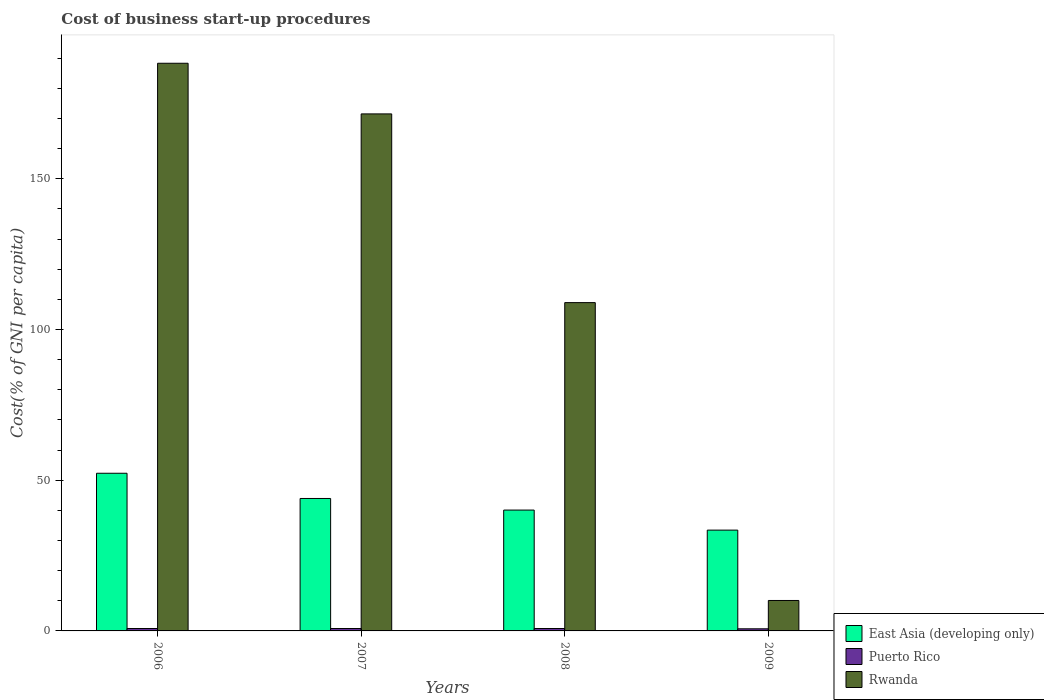How many groups of bars are there?
Your answer should be very brief. 4. Are the number of bars per tick equal to the number of legend labels?
Provide a succinct answer. Yes. Are the number of bars on each tick of the X-axis equal?
Your answer should be compact. Yes. How many bars are there on the 4th tick from the right?
Your response must be concise. 3. What is the label of the 2nd group of bars from the left?
Give a very brief answer. 2007. In how many cases, is the number of bars for a given year not equal to the number of legend labels?
Give a very brief answer. 0. What is the cost of business start-up procedures in East Asia (developing only) in 2009?
Ensure brevity in your answer.  33.44. Across all years, what is the minimum cost of business start-up procedures in East Asia (developing only)?
Your response must be concise. 33.44. What is the total cost of business start-up procedures in Rwanda in the graph?
Ensure brevity in your answer.  478.8. What is the difference between the cost of business start-up procedures in East Asia (developing only) in 2007 and the cost of business start-up procedures in Rwanda in 2008?
Provide a short and direct response. -64.97. What is the average cost of business start-up procedures in East Asia (developing only) per year?
Keep it short and to the point. 42.44. In the year 2007, what is the difference between the cost of business start-up procedures in Rwanda and cost of business start-up procedures in Puerto Rico?
Make the answer very short. 170.7. What is the ratio of the cost of business start-up procedures in East Asia (developing only) in 2006 to that in 2007?
Give a very brief answer. 1.19. Is the difference between the cost of business start-up procedures in Rwanda in 2008 and 2009 greater than the difference between the cost of business start-up procedures in Puerto Rico in 2008 and 2009?
Offer a very short reply. Yes. What is the difference between the highest and the second highest cost of business start-up procedures in East Asia (developing only)?
Provide a succinct answer. 8.37. What is the difference between the highest and the lowest cost of business start-up procedures in Rwanda?
Provide a succinct answer. 178.2. Is the sum of the cost of business start-up procedures in East Asia (developing only) in 2008 and 2009 greater than the maximum cost of business start-up procedures in Rwanda across all years?
Keep it short and to the point. No. What does the 2nd bar from the left in 2009 represents?
Offer a very short reply. Puerto Rico. What does the 3rd bar from the right in 2009 represents?
Give a very brief answer. East Asia (developing only). Is it the case that in every year, the sum of the cost of business start-up procedures in East Asia (developing only) and cost of business start-up procedures in Puerto Rico is greater than the cost of business start-up procedures in Rwanda?
Keep it short and to the point. No. How many bars are there?
Provide a succinct answer. 12. Does the graph contain any zero values?
Your response must be concise. No. Does the graph contain grids?
Your answer should be very brief. No. What is the title of the graph?
Your response must be concise. Cost of business start-up procedures. What is the label or title of the Y-axis?
Provide a succinct answer. Cost(% of GNI per capita). What is the Cost(% of GNI per capita) of East Asia (developing only) in 2006?
Offer a very short reply. 52.3. What is the Cost(% of GNI per capita) in Rwanda in 2006?
Your response must be concise. 188.3. What is the Cost(% of GNI per capita) in East Asia (developing only) in 2007?
Provide a short and direct response. 43.93. What is the Cost(% of GNI per capita) in Rwanda in 2007?
Offer a very short reply. 171.5. What is the Cost(% of GNI per capita) of East Asia (developing only) in 2008?
Provide a succinct answer. 40.09. What is the Cost(% of GNI per capita) of Rwanda in 2008?
Your answer should be very brief. 108.9. What is the Cost(% of GNI per capita) in East Asia (developing only) in 2009?
Give a very brief answer. 33.44. What is the Cost(% of GNI per capita) of Rwanda in 2009?
Keep it short and to the point. 10.1. Across all years, what is the maximum Cost(% of GNI per capita) in East Asia (developing only)?
Your answer should be very brief. 52.3. Across all years, what is the maximum Cost(% of GNI per capita) in Rwanda?
Your response must be concise. 188.3. Across all years, what is the minimum Cost(% of GNI per capita) of East Asia (developing only)?
Offer a terse response. 33.44. Across all years, what is the minimum Cost(% of GNI per capita) in Puerto Rico?
Provide a short and direct response. 0.7. What is the total Cost(% of GNI per capita) of East Asia (developing only) in the graph?
Offer a terse response. 169.76. What is the total Cost(% of GNI per capita) in Rwanda in the graph?
Give a very brief answer. 478.8. What is the difference between the Cost(% of GNI per capita) in East Asia (developing only) in 2006 and that in 2007?
Make the answer very short. 8.37. What is the difference between the Cost(% of GNI per capita) of Puerto Rico in 2006 and that in 2007?
Provide a short and direct response. 0. What is the difference between the Cost(% of GNI per capita) in East Asia (developing only) in 2006 and that in 2008?
Offer a terse response. 12.21. What is the difference between the Cost(% of GNI per capita) of Puerto Rico in 2006 and that in 2008?
Offer a terse response. 0. What is the difference between the Cost(% of GNI per capita) in Rwanda in 2006 and that in 2008?
Keep it short and to the point. 79.4. What is the difference between the Cost(% of GNI per capita) in East Asia (developing only) in 2006 and that in 2009?
Your response must be concise. 18.86. What is the difference between the Cost(% of GNI per capita) of Rwanda in 2006 and that in 2009?
Keep it short and to the point. 178.2. What is the difference between the Cost(% of GNI per capita) of East Asia (developing only) in 2007 and that in 2008?
Provide a succinct answer. 3.84. What is the difference between the Cost(% of GNI per capita) in Puerto Rico in 2007 and that in 2008?
Provide a short and direct response. 0. What is the difference between the Cost(% of GNI per capita) in Rwanda in 2007 and that in 2008?
Offer a very short reply. 62.6. What is the difference between the Cost(% of GNI per capita) in East Asia (developing only) in 2007 and that in 2009?
Your answer should be very brief. 10.49. What is the difference between the Cost(% of GNI per capita) of Rwanda in 2007 and that in 2009?
Your answer should be compact. 161.4. What is the difference between the Cost(% of GNI per capita) of East Asia (developing only) in 2008 and that in 2009?
Make the answer very short. 6.65. What is the difference between the Cost(% of GNI per capita) in Rwanda in 2008 and that in 2009?
Provide a succinct answer. 98.8. What is the difference between the Cost(% of GNI per capita) in East Asia (developing only) in 2006 and the Cost(% of GNI per capita) in Puerto Rico in 2007?
Ensure brevity in your answer.  51.5. What is the difference between the Cost(% of GNI per capita) of East Asia (developing only) in 2006 and the Cost(% of GNI per capita) of Rwanda in 2007?
Your response must be concise. -119.2. What is the difference between the Cost(% of GNI per capita) of Puerto Rico in 2006 and the Cost(% of GNI per capita) of Rwanda in 2007?
Offer a terse response. -170.7. What is the difference between the Cost(% of GNI per capita) of East Asia (developing only) in 2006 and the Cost(% of GNI per capita) of Puerto Rico in 2008?
Your answer should be very brief. 51.5. What is the difference between the Cost(% of GNI per capita) in East Asia (developing only) in 2006 and the Cost(% of GNI per capita) in Rwanda in 2008?
Give a very brief answer. -56.6. What is the difference between the Cost(% of GNI per capita) of Puerto Rico in 2006 and the Cost(% of GNI per capita) of Rwanda in 2008?
Offer a very short reply. -108.1. What is the difference between the Cost(% of GNI per capita) in East Asia (developing only) in 2006 and the Cost(% of GNI per capita) in Puerto Rico in 2009?
Your response must be concise. 51.6. What is the difference between the Cost(% of GNI per capita) of East Asia (developing only) in 2006 and the Cost(% of GNI per capita) of Rwanda in 2009?
Your answer should be compact. 42.2. What is the difference between the Cost(% of GNI per capita) in Puerto Rico in 2006 and the Cost(% of GNI per capita) in Rwanda in 2009?
Make the answer very short. -9.3. What is the difference between the Cost(% of GNI per capita) in East Asia (developing only) in 2007 and the Cost(% of GNI per capita) in Puerto Rico in 2008?
Give a very brief answer. 43.13. What is the difference between the Cost(% of GNI per capita) in East Asia (developing only) in 2007 and the Cost(% of GNI per capita) in Rwanda in 2008?
Keep it short and to the point. -64.97. What is the difference between the Cost(% of GNI per capita) in Puerto Rico in 2007 and the Cost(% of GNI per capita) in Rwanda in 2008?
Make the answer very short. -108.1. What is the difference between the Cost(% of GNI per capita) of East Asia (developing only) in 2007 and the Cost(% of GNI per capita) of Puerto Rico in 2009?
Provide a succinct answer. 43.23. What is the difference between the Cost(% of GNI per capita) in East Asia (developing only) in 2007 and the Cost(% of GNI per capita) in Rwanda in 2009?
Offer a very short reply. 33.83. What is the difference between the Cost(% of GNI per capita) in East Asia (developing only) in 2008 and the Cost(% of GNI per capita) in Puerto Rico in 2009?
Your answer should be very brief. 39.39. What is the difference between the Cost(% of GNI per capita) of East Asia (developing only) in 2008 and the Cost(% of GNI per capita) of Rwanda in 2009?
Provide a succinct answer. 29.99. What is the difference between the Cost(% of GNI per capita) of Puerto Rico in 2008 and the Cost(% of GNI per capita) of Rwanda in 2009?
Your answer should be compact. -9.3. What is the average Cost(% of GNI per capita) of East Asia (developing only) per year?
Give a very brief answer. 42.44. What is the average Cost(% of GNI per capita) in Puerto Rico per year?
Provide a short and direct response. 0.78. What is the average Cost(% of GNI per capita) of Rwanda per year?
Your answer should be compact. 119.7. In the year 2006, what is the difference between the Cost(% of GNI per capita) in East Asia (developing only) and Cost(% of GNI per capita) in Puerto Rico?
Provide a succinct answer. 51.5. In the year 2006, what is the difference between the Cost(% of GNI per capita) in East Asia (developing only) and Cost(% of GNI per capita) in Rwanda?
Give a very brief answer. -136. In the year 2006, what is the difference between the Cost(% of GNI per capita) of Puerto Rico and Cost(% of GNI per capita) of Rwanda?
Offer a terse response. -187.5. In the year 2007, what is the difference between the Cost(% of GNI per capita) in East Asia (developing only) and Cost(% of GNI per capita) in Puerto Rico?
Give a very brief answer. 43.13. In the year 2007, what is the difference between the Cost(% of GNI per capita) of East Asia (developing only) and Cost(% of GNI per capita) of Rwanda?
Make the answer very short. -127.57. In the year 2007, what is the difference between the Cost(% of GNI per capita) in Puerto Rico and Cost(% of GNI per capita) in Rwanda?
Ensure brevity in your answer.  -170.7. In the year 2008, what is the difference between the Cost(% of GNI per capita) of East Asia (developing only) and Cost(% of GNI per capita) of Puerto Rico?
Your response must be concise. 39.29. In the year 2008, what is the difference between the Cost(% of GNI per capita) in East Asia (developing only) and Cost(% of GNI per capita) in Rwanda?
Ensure brevity in your answer.  -68.81. In the year 2008, what is the difference between the Cost(% of GNI per capita) in Puerto Rico and Cost(% of GNI per capita) in Rwanda?
Offer a terse response. -108.1. In the year 2009, what is the difference between the Cost(% of GNI per capita) in East Asia (developing only) and Cost(% of GNI per capita) in Puerto Rico?
Make the answer very short. 32.74. In the year 2009, what is the difference between the Cost(% of GNI per capita) of East Asia (developing only) and Cost(% of GNI per capita) of Rwanda?
Offer a terse response. 23.34. What is the ratio of the Cost(% of GNI per capita) of East Asia (developing only) in 2006 to that in 2007?
Keep it short and to the point. 1.19. What is the ratio of the Cost(% of GNI per capita) in Puerto Rico in 2006 to that in 2007?
Offer a terse response. 1. What is the ratio of the Cost(% of GNI per capita) in Rwanda in 2006 to that in 2007?
Provide a succinct answer. 1.1. What is the ratio of the Cost(% of GNI per capita) in East Asia (developing only) in 2006 to that in 2008?
Your answer should be very brief. 1.3. What is the ratio of the Cost(% of GNI per capita) in Puerto Rico in 2006 to that in 2008?
Offer a terse response. 1. What is the ratio of the Cost(% of GNI per capita) in Rwanda in 2006 to that in 2008?
Ensure brevity in your answer.  1.73. What is the ratio of the Cost(% of GNI per capita) of East Asia (developing only) in 2006 to that in 2009?
Make the answer very short. 1.56. What is the ratio of the Cost(% of GNI per capita) in Rwanda in 2006 to that in 2009?
Your response must be concise. 18.64. What is the ratio of the Cost(% of GNI per capita) in East Asia (developing only) in 2007 to that in 2008?
Offer a very short reply. 1.1. What is the ratio of the Cost(% of GNI per capita) of Rwanda in 2007 to that in 2008?
Your response must be concise. 1.57. What is the ratio of the Cost(% of GNI per capita) of East Asia (developing only) in 2007 to that in 2009?
Offer a very short reply. 1.31. What is the ratio of the Cost(% of GNI per capita) in Puerto Rico in 2007 to that in 2009?
Your answer should be very brief. 1.14. What is the ratio of the Cost(% of GNI per capita) of Rwanda in 2007 to that in 2009?
Make the answer very short. 16.98. What is the ratio of the Cost(% of GNI per capita) of East Asia (developing only) in 2008 to that in 2009?
Provide a short and direct response. 1.2. What is the ratio of the Cost(% of GNI per capita) of Rwanda in 2008 to that in 2009?
Your answer should be very brief. 10.78. What is the difference between the highest and the second highest Cost(% of GNI per capita) in East Asia (developing only)?
Ensure brevity in your answer.  8.37. What is the difference between the highest and the second highest Cost(% of GNI per capita) of Puerto Rico?
Offer a very short reply. 0. What is the difference between the highest and the second highest Cost(% of GNI per capita) of Rwanda?
Ensure brevity in your answer.  16.8. What is the difference between the highest and the lowest Cost(% of GNI per capita) in East Asia (developing only)?
Offer a terse response. 18.86. What is the difference between the highest and the lowest Cost(% of GNI per capita) of Rwanda?
Your answer should be compact. 178.2. 